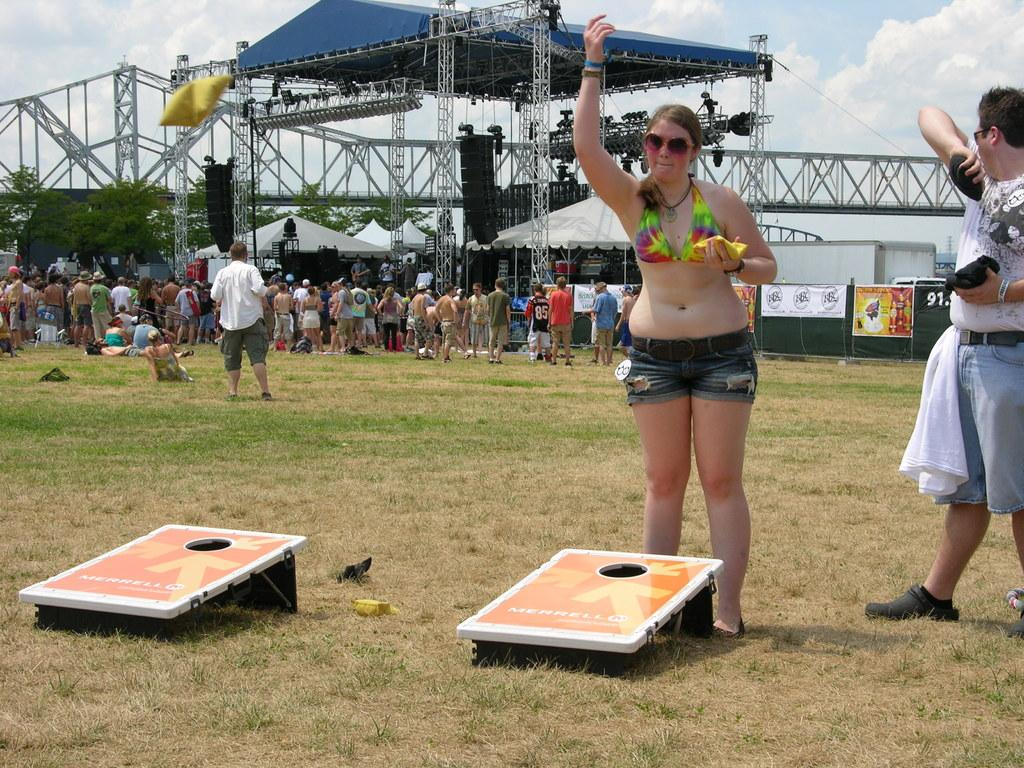What is the primary vegetation covering the land in the image? The land is covered with grass. Can you describe the people in the image? There are people in the image, but their specific actions or appearances are not mentioned in the facts. What structures are visible in the background of the image? There is an open shed, a tent, and speakers in the background. What additional decorations or signage are present in the background? There are banners in the background. What type of trees are visible in the background? The facts do not specify the type of trees, only that there are trees in the background. What are the two people holding in the image? The facts mention that two people are holding objects, but their specific objects are not described. What is the weather like in the image? The sky is cloudy in the image. What type of ice can be seen melting on the wall in the image? There is no ice or wall present in the image. What kind of stick is being used by the people in the image? The facts do not mention any sticks being used by the people in the image. 